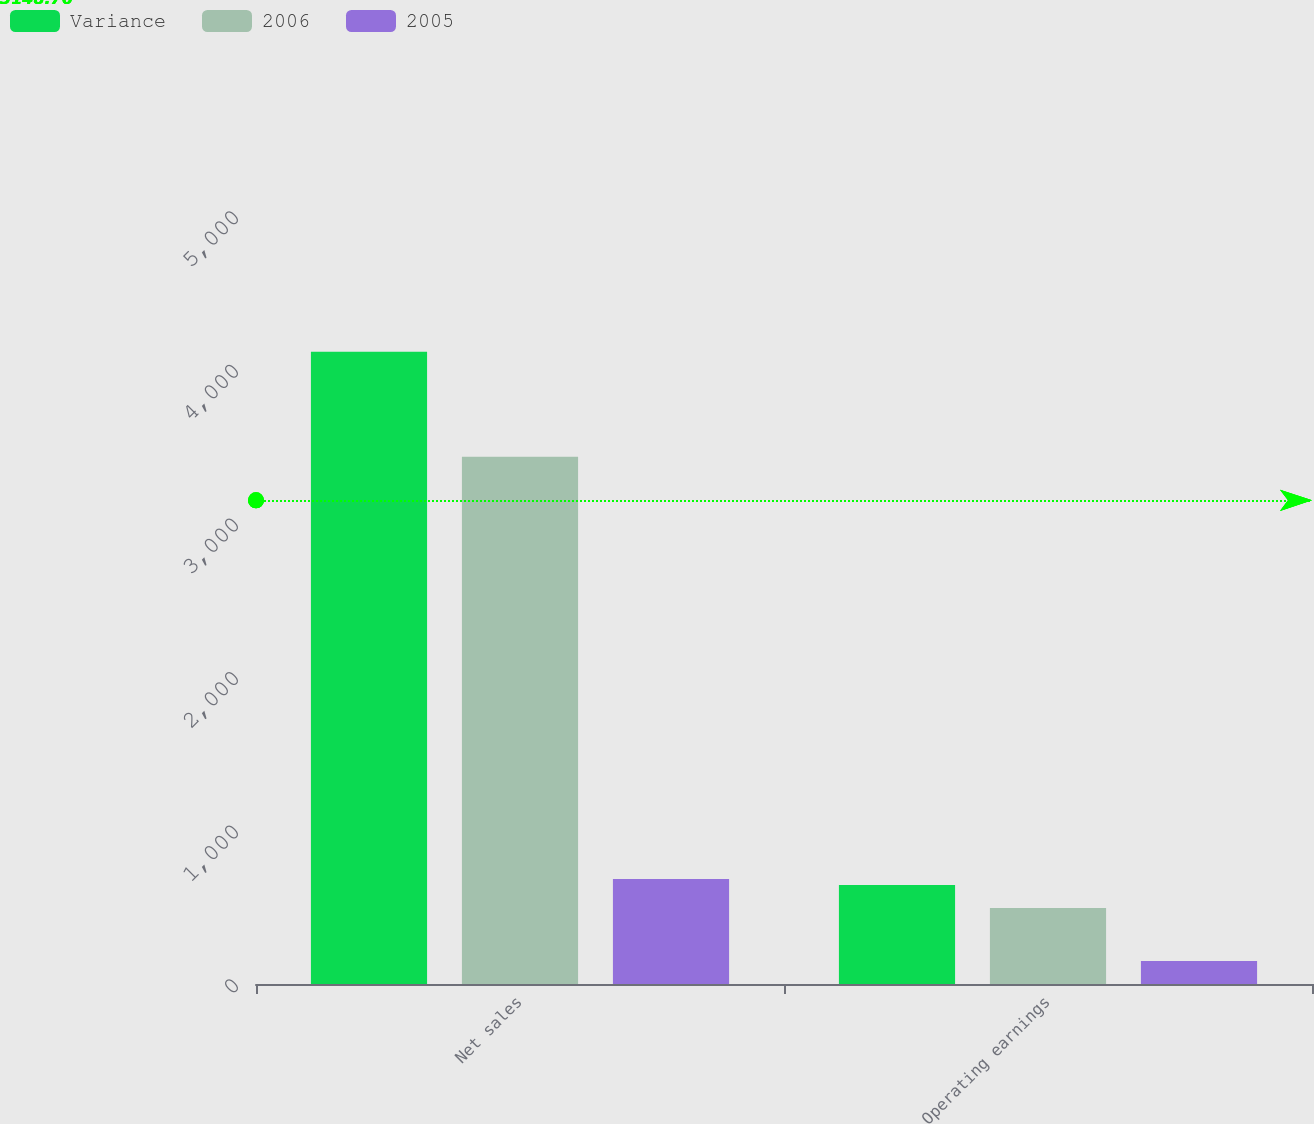Convert chart to OTSL. <chart><loc_0><loc_0><loc_500><loc_500><stacked_bar_chart><ecel><fcel>Net sales<fcel>Operating earnings<nl><fcel>Variance<fcel>4116<fcel>644<nl><fcel>2006<fcel>3433<fcel>495<nl><fcel>2005<fcel>683<fcel>149<nl></chart> 